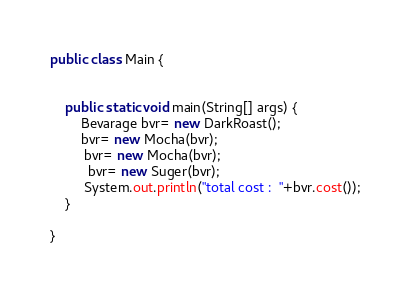<code> <loc_0><loc_0><loc_500><loc_500><_Java_>public class Main {

    
    public static void main(String[] args) {
        Bevarage bvr= new DarkRoast();
        bvr= new Mocha(bvr);
         bvr= new Mocha(bvr);
          bvr= new Suger(bvr);
         System.out.println("total cost :  "+bvr.cost());
    }
    
}</code> 